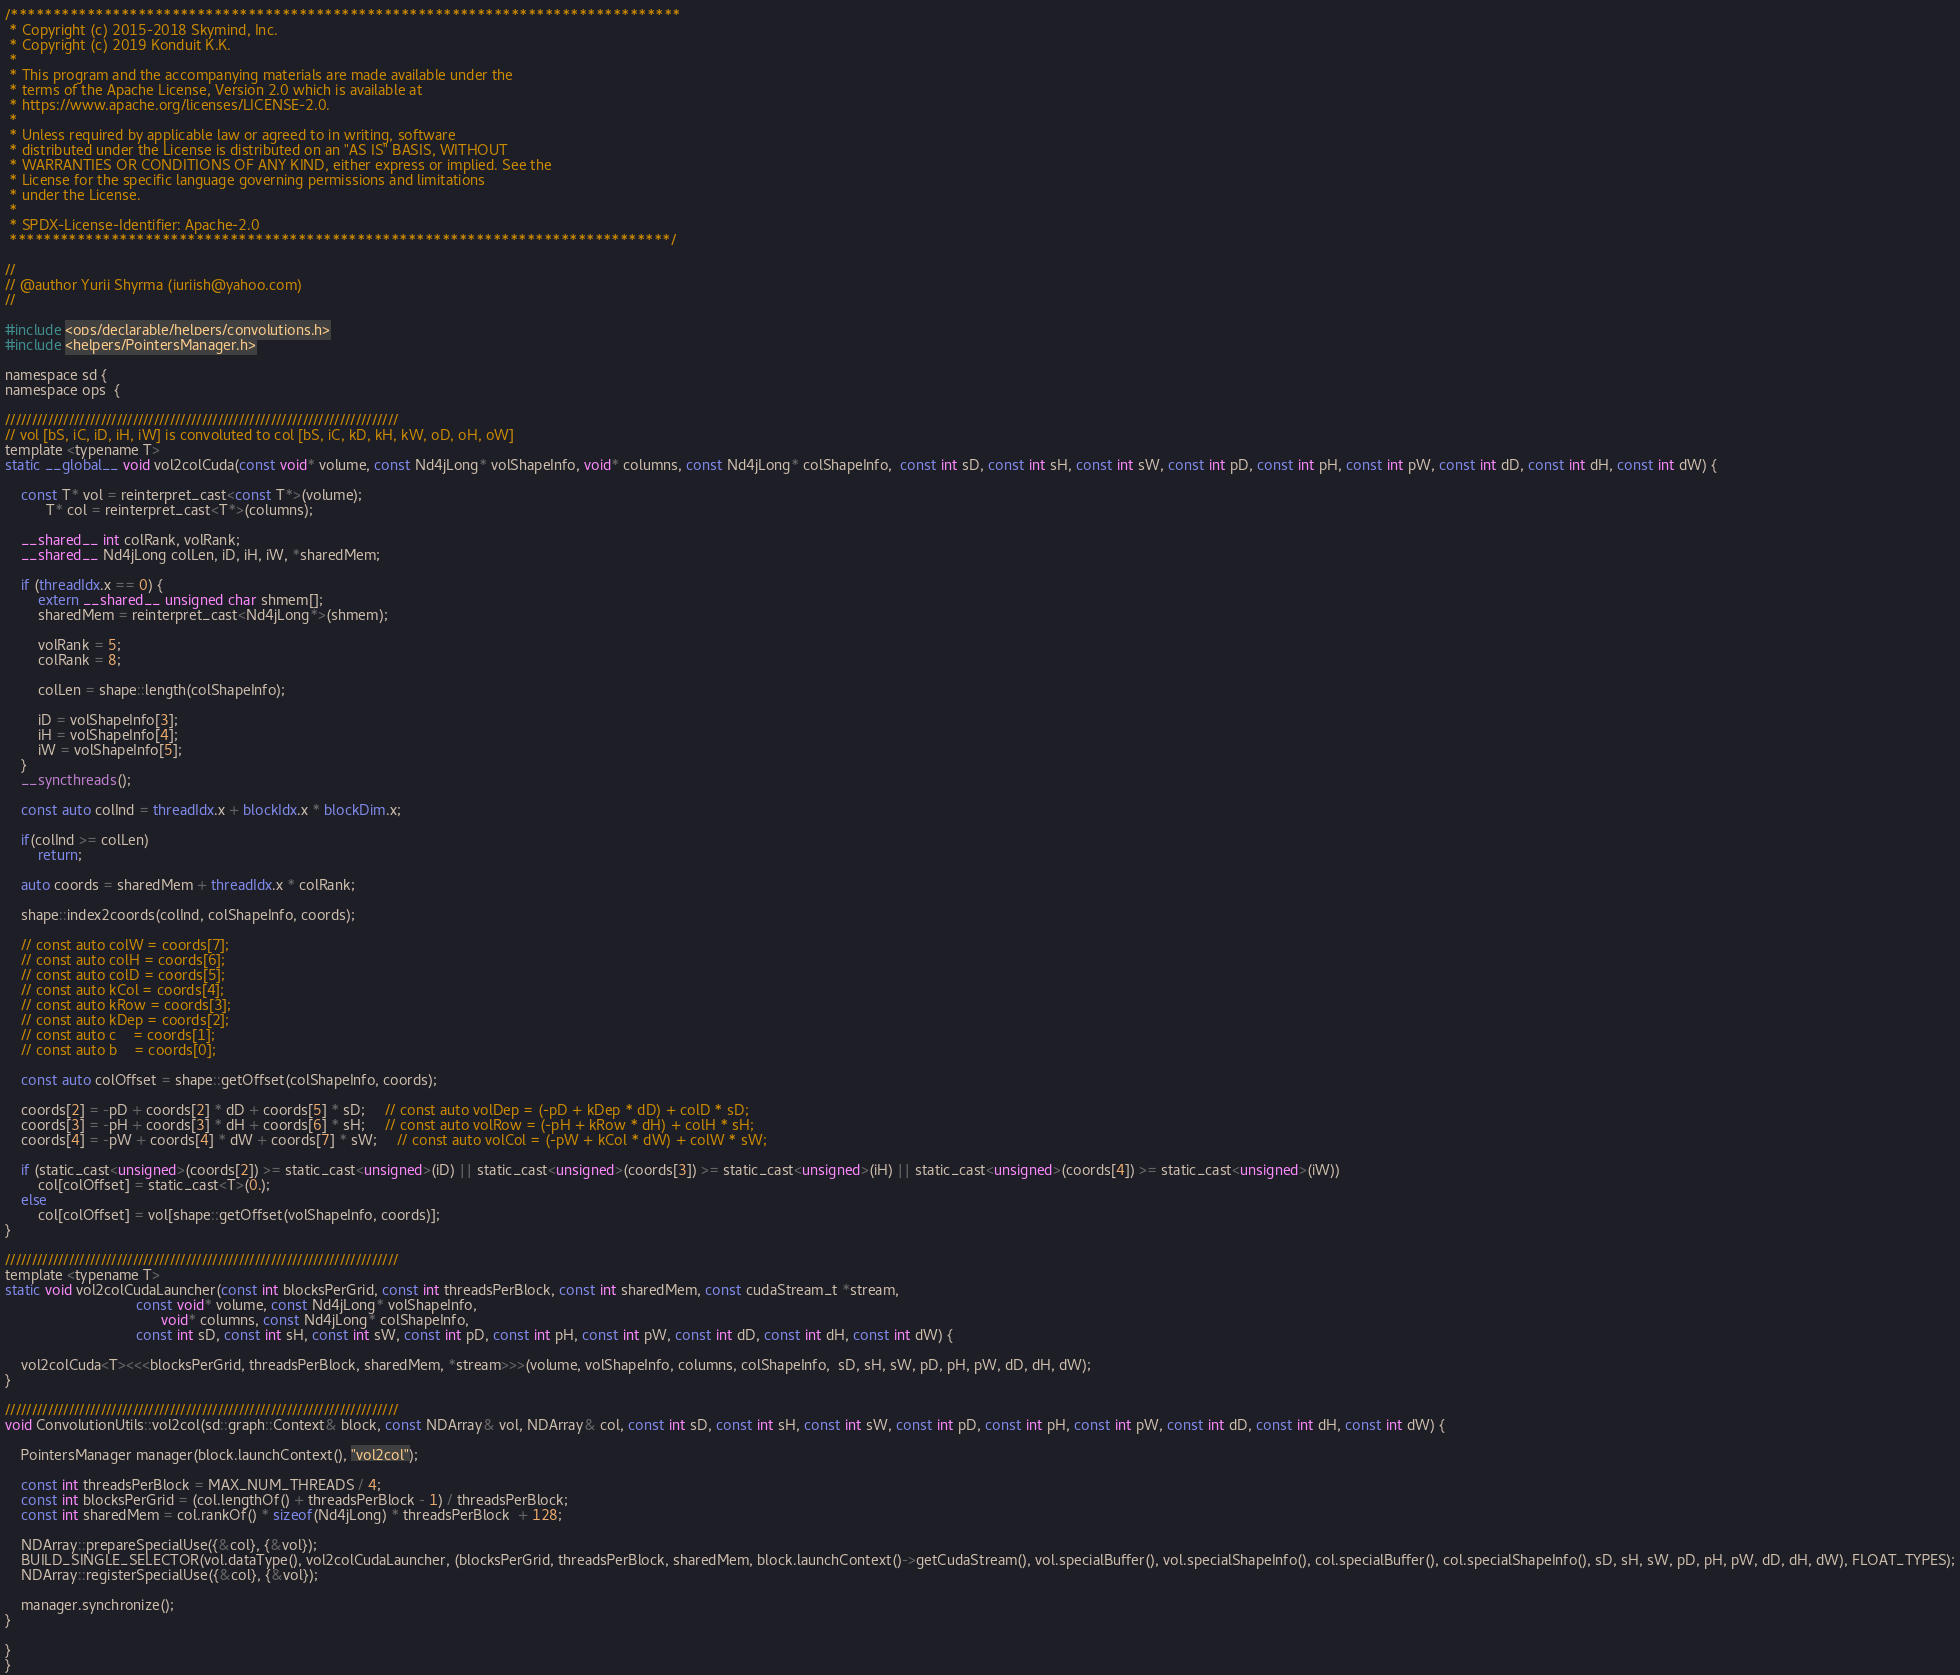Convert code to text. <code><loc_0><loc_0><loc_500><loc_500><_Cuda_>/*******************************************************************************
 * Copyright (c) 2015-2018 Skymind, Inc.
 * Copyright (c) 2019 Konduit K.K.
 *
 * This program and the accompanying materials are made available under the
 * terms of the Apache License, Version 2.0 which is available at
 * https://www.apache.org/licenses/LICENSE-2.0.
 *
 * Unless required by applicable law or agreed to in writing, software
 * distributed under the License is distributed on an "AS IS" BASIS, WITHOUT
 * WARRANTIES OR CONDITIONS OF ANY KIND, either express or implied. See the
 * License for the specific language governing permissions and limitations
 * under the License.
 *
 * SPDX-License-Identifier: Apache-2.0
 ******************************************************************************/

//
// @author Yurii Shyrma (iuriish@yahoo.com)
//

#include <ops/declarable/helpers/convolutions.h>
#include <helpers/PointersManager.h>

namespace sd {
namespace ops  {

//////////////////////////////////////////////////////////////////////////
// vol [bS, iC, iD, iH, iW] is convoluted to col [bS, iC, kD, kH, kW, oD, oH, oW]
template <typename T>
static __global__ void vol2colCuda(const void* volume, const Nd4jLong* volShapeInfo, void* columns, const Nd4jLong* colShapeInfo,  const int sD, const int sH, const int sW, const int pD, const int pH, const int pW, const int dD, const int dH, const int dW) {

    const T* vol = reinterpret_cast<const T*>(volume);
          T* col = reinterpret_cast<T*>(columns);

    __shared__ int colRank, volRank;
    __shared__ Nd4jLong colLen, iD, iH, iW, *sharedMem;

    if (threadIdx.x == 0) {
        extern __shared__ unsigned char shmem[];
        sharedMem = reinterpret_cast<Nd4jLong*>(shmem);

        volRank = 5;
        colRank = 8;

        colLen = shape::length(colShapeInfo);

        iD = volShapeInfo[3];
        iH = volShapeInfo[4];
        iW = volShapeInfo[5];
    }
    __syncthreads();

    const auto colInd = threadIdx.x + blockIdx.x * blockDim.x;

    if(colInd >= colLen)
        return;

    auto coords = sharedMem + threadIdx.x * colRank;

    shape::index2coords(colInd, colShapeInfo, coords);

    // const auto colW = coords[7];
    // const auto colH = coords[6];
    // const auto colD = coords[5];
    // const auto kCol = coords[4];
    // const auto kRow = coords[3];
    // const auto kDep = coords[2];
    // const auto c    = coords[1];
    // const auto b    = coords[0];

    const auto colOffset = shape::getOffset(colShapeInfo, coords);

    coords[2] = -pD + coords[2] * dD + coords[5] * sD;     // const auto volDep = (-pD + kDep * dD) + colD * sD;
    coords[3] = -pH + coords[3] * dH + coords[6] * sH;     // const auto volRow = (-pH + kRow * dH) + colH * sH;
    coords[4] = -pW + coords[4] * dW + coords[7] * sW;     // const auto volCol = (-pW + kCol * dW) + colW * sW;

    if (static_cast<unsigned>(coords[2]) >= static_cast<unsigned>(iD) || static_cast<unsigned>(coords[3]) >= static_cast<unsigned>(iH) || static_cast<unsigned>(coords[4]) >= static_cast<unsigned>(iW))
        col[colOffset] = static_cast<T>(0.);
    else
        col[colOffset] = vol[shape::getOffset(volShapeInfo, coords)];
}

//////////////////////////////////////////////////////////////////////////
template <typename T>
static void vol2colCudaLauncher(const int blocksPerGrid, const int threadsPerBlock, const int sharedMem, const cudaStream_t *stream,
                                const void* volume, const Nd4jLong* volShapeInfo,
                                      void* columns, const Nd4jLong* colShapeInfo,
                                const int sD, const int sH, const int sW, const int pD, const int pH, const int pW, const int dD, const int dH, const int dW) {

    vol2colCuda<T><<<blocksPerGrid, threadsPerBlock, sharedMem, *stream>>>(volume, volShapeInfo, columns, colShapeInfo,  sD, sH, sW, pD, pH, pW, dD, dH, dW);
}

//////////////////////////////////////////////////////////////////////////
void ConvolutionUtils::vol2col(sd::graph::Context& block, const NDArray& vol, NDArray& col, const int sD, const int sH, const int sW, const int pD, const int pH, const int pW, const int dD, const int dH, const int dW) {

    PointersManager manager(block.launchContext(), "vol2col");

    const int threadsPerBlock = MAX_NUM_THREADS / 4;
    const int blocksPerGrid = (col.lengthOf() + threadsPerBlock - 1) / threadsPerBlock;
    const int sharedMem = col.rankOf() * sizeof(Nd4jLong) * threadsPerBlock  + 128;

    NDArray::prepareSpecialUse({&col}, {&vol});
    BUILD_SINGLE_SELECTOR(vol.dataType(), vol2colCudaLauncher, (blocksPerGrid, threadsPerBlock, sharedMem, block.launchContext()->getCudaStream(), vol.specialBuffer(), vol.specialShapeInfo(), col.specialBuffer(), col.specialShapeInfo(), sD, sH, sW, pD, pH, pW, dD, dH, dW), FLOAT_TYPES);
    NDArray::registerSpecialUse({&col}, {&vol});

    manager.synchronize();
}

}
}</code> 